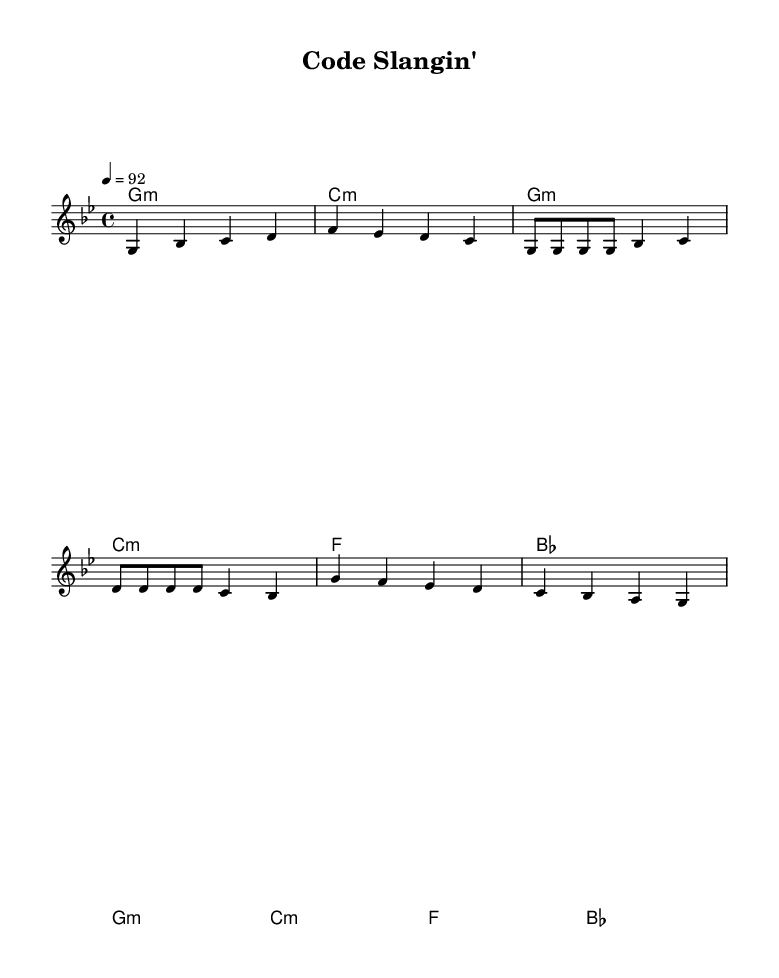What is the key signature of this music? The key signature is G minor, which has two flats (B flat and E flat).
Answer: G minor What is the time signature of the piece? The time signature is indicated as 4/4, meaning there are four beats in each measure and a quarter note gets one beat.
Answer: 4/4 What is the tempo marking in BPM? The tempo marking indicates a speed of 92 beats per minute, which is shown by the number after the tempo instruction.
Answer: 92 How many lines are in the chorus section? In the score, the chorus section consists of two lines of lyrics beneath the melody, as seen in the layout of the lyrics.
Answer: 2 What chord follows the melody in the chorus? The chord that follows the melody in the chorus is G minor, as indicated at the start of the chorus measures in the harmonies above.
Answer: G minor What is the first programming language mentioned in the verse? The first programming language mentioned in the verse is Python, noted clearly in the lyrics that follow the melody.
Answer: Python What is the rhyme scheme of the verse based on the lyrics? The rhyme scheme can be analyzed by looking at the end of each line in the verse; the words "hood" and "block" rhyme, and they form a couplet, creating a pattern.
Answer: AABB 